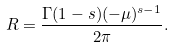Convert formula to latex. <formula><loc_0><loc_0><loc_500><loc_500>R = \frac { \Gamma ( 1 - s ) ( - \mu ) ^ { s - 1 } } { 2 \pi } .</formula> 